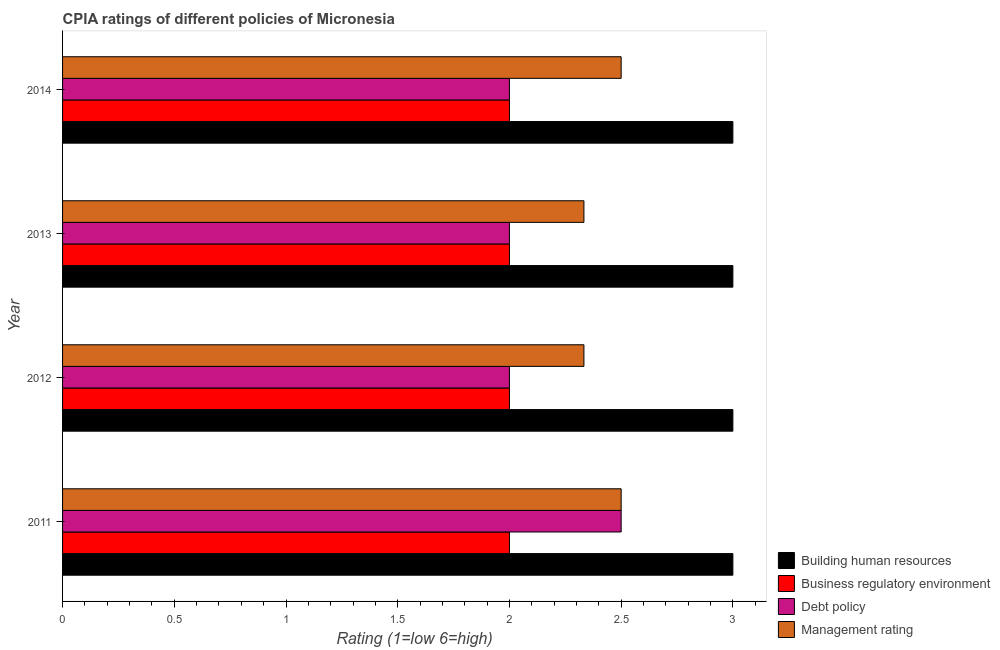How many bars are there on the 4th tick from the top?
Provide a succinct answer. 4. How many bars are there on the 3rd tick from the bottom?
Keep it short and to the point. 4. In how many cases, is the number of bars for a given year not equal to the number of legend labels?
Provide a short and direct response. 0. What is the cpia rating of debt policy in 2014?
Offer a terse response. 2. Across all years, what is the maximum cpia rating of building human resources?
Your answer should be compact. 3. Across all years, what is the minimum cpia rating of building human resources?
Ensure brevity in your answer.  3. In which year was the cpia rating of debt policy maximum?
Your answer should be compact. 2011. What is the total cpia rating of building human resources in the graph?
Provide a short and direct response. 12. What is the difference between the cpia rating of management in 2013 and the cpia rating of debt policy in 2012?
Your answer should be very brief. 0.33. What is the average cpia rating of debt policy per year?
Provide a succinct answer. 2.12. In the year 2013, what is the difference between the cpia rating of business regulatory environment and cpia rating of debt policy?
Ensure brevity in your answer.  0. What is the ratio of the cpia rating of business regulatory environment in 2011 to that in 2013?
Provide a succinct answer. 1. Is the cpia rating of building human resources in 2011 less than that in 2012?
Offer a terse response. No. Is the difference between the cpia rating of management in 2013 and 2014 greater than the difference between the cpia rating of business regulatory environment in 2013 and 2014?
Your response must be concise. No. Is it the case that in every year, the sum of the cpia rating of management and cpia rating of business regulatory environment is greater than the sum of cpia rating of building human resources and cpia rating of debt policy?
Your answer should be compact. Yes. What does the 3rd bar from the top in 2013 represents?
Ensure brevity in your answer.  Business regulatory environment. What does the 4th bar from the bottom in 2012 represents?
Provide a succinct answer. Management rating. Is it the case that in every year, the sum of the cpia rating of building human resources and cpia rating of business regulatory environment is greater than the cpia rating of debt policy?
Ensure brevity in your answer.  Yes. How many bars are there?
Offer a terse response. 16. How many years are there in the graph?
Your response must be concise. 4. Are the values on the major ticks of X-axis written in scientific E-notation?
Provide a succinct answer. No. Does the graph contain any zero values?
Provide a short and direct response. No. How are the legend labels stacked?
Provide a succinct answer. Vertical. What is the title of the graph?
Provide a short and direct response. CPIA ratings of different policies of Micronesia. Does "United Kingdom" appear as one of the legend labels in the graph?
Your answer should be very brief. No. What is the label or title of the X-axis?
Ensure brevity in your answer.  Rating (1=low 6=high). What is the label or title of the Y-axis?
Your answer should be compact. Year. What is the Rating (1=low 6=high) in Debt policy in 2011?
Provide a succinct answer. 2.5. What is the Rating (1=low 6=high) of Management rating in 2011?
Make the answer very short. 2.5. What is the Rating (1=low 6=high) of Building human resources in 2012?
Keep it short and to the point. 3. What is the Rating (1=low 6=high) in Management rating in 2012?
Offer a terse response. 2.33. What is the Rating (1=low 6=high) of Building human resources in 2013?
Your answer should be compact. 3. What is the Rating (1=low 6=high) of Business regulatory environment in 2013?
Provide a succinct answer. 2. What is the Rating (1=low 6=high) of Management rating in 2013?
Offer a very short reply. 2.33. What is the Rating (1=low 6=high) in Business regulatory environment in 2014?
Keep it short and to the point. 2. What is the Rating (1=low 6=high) in Management rating in 2014?
Offer a terse response. 2.5. Across all years, what is the maximum Rating (1=low 6=high) in Building human resources?
Give a very brief answer. 3. Across all years, what is the maximum Rating (1=low 6=high) in Debt policy?
Provide a short and direct response. 2.5. Across all years, what is the minimum Rating (1=low 6=high) of Building human resources?
Make the answer very short. 3. Across all years, what is the minimum Rating (1=low 6=high) in Business regulatory environment?
Give a very brief answer. 2. Across all years, what is the minimum Rating (1=low 6=high) of Debt policy?
Provide a succinct answer. 2. Across all years, what is the minimum Rating (1=low 6=high) in Management rating?
Provide a succinct answer. 2.33. What is the total Rating (1=low 6=high) in Business regulatory environment in the graph?
Give a very brief answer. 8. What is the total Rating (1=low 6=high) of Debt policy in the graph?
Your response must be concise. 8.5. What is the total Rating (1=low 6=high) in Management rating in the graph?
Provide a succinct answer. 9.67. What is the difference between the Rating (1=low 6=high) in Building human resources in 2011 and that in 2012?
Make the answer very short. 0. What is the difference between the Rating (1=low 6=high) in Business regulatory environment in 2011 and that in 2012?
Keep it short and to the point. 0. What is the difference between the Rating (1=low 6=high) of Debt policy in 2011 and that in 2012?
Keep it short and to the point. 0.5. What is the difference between the Rating (1=low 6=high) in Debt policy in 2011 and that in 2013?
Provide a short and direct response. 0.5. What is the difference between the Rating (1=low 6=high) in Building human resources in 2011 and that in 2014?
Provide a short and direct response. 0. What is the difference between the Rating (1=low 6=high) in Business regulatory environment in 2012 and that in 2013?
Your response must be concise. 0. What is the difference between the Rating (1=low 6=high) in Debt policy in 2012 and that in 2013?
Offer a terse response. 0. What is the difference between the Rating (1=low 6=high) of Management rating in 2012 and that in 2013?
Offer a terse response. 0. What is the difference between the Rating (1=low 6=high) in Management rating in 2012 and that in 2014?
Your answer should be very brief. -0.17. What is the difference between the Rating (1=low 6=high) of Building human resources in 2013 and that in 2014?
Your answer should be compact. 0. What is the difference between the Rating (1=low 6=high) of Debt policy in 2013 and that in 2014?
Your answer should be very brief. 0. What is the difference between the Rating (1=low 6=high) in Management rating in 2013 and that in 2014?
Keep it short and to the point. -0.17. What is the difference between the Rating (1=low 6=high) of Building human resources in 2011 and the Rating (1=low 6=high) of Debt policy in 2012?
Make the answer very short. 1. What is the difference between the Rating (1=low 6=high) of Building human resources in 2011 and the Rating (1=low 6=high) of Management rating in 2012?
Your answer should be compact. 0.67. What is the difference between the Rating (1=low 6=high) of Business regulatory environment in 2011 and the Rating (1=low 6=high) of Management rating in 2012?
Give a very brief answer. -0.33. What is the difference between the Rating (1=low 6=high) of Debt policy in 2011 and the Rating (1=low 6=high) of Management rating in 2012?
Provide a short and direct response. 0.17. What is the difference between the Rating (1=low 6=high) in Building human resources in 2011 and the Rating (1=low 6=high) in Business regulatory environment in 2013?
Your response must be concise. 1. What is the difference between the Rating (1=low 6=high) of Business regulatory environment in 2011 and the Rating (1=low 6=high) of Debt policy in 2013?
Provide a short and direct response. 0. What is the difference between the Rating (1=low 6=high) in Debt policy in 2011 and the Rating (1=low 6=high) in Management rating in 2013?
Ensure brevity in your answer.  0.17. What is the difference between the Rating (1=low 6=high) in Building human resources in 2011 and the Rating (1=low 6=high) in Business regulatory environment in 2014?
Keep it short and to the point. 1. What is the difference between the Rating (1=low 6=high) of Business regulatory environment in 2011 and the Rating (1=low 6=high) of Management rating in 2014?
Keep it short and to the point. -0.5. What is the difference between the Rating (1=low 6=high) of Debt policy in 2011 and the Rating (1=low 6=high) of Management rating in 2014?
Keep it short and to the point. 0. What is the difference between the Rating (1=low 6=high) in Building human resources in 2012 and the Rating (1=low 6=high) in Business regulatory environment in 2013?
Make the answer very short. 1. What is the difference between the Rating (1=low 6=high) of Building human resources in 2012 and the Rating (1=low 6=high) of Debt policy in 2013?
Offer a terse response. 1. What is the difference between the Rating (1=low 6=high) in Building human resources in 2012 and the Rating (1=low 6=high) in Management rating in 2013?
Keep it short and to the point. 0.67. What is the difference between the Rating (1=low 6=high) of Business regulatory environment in 2012 and the Rating (1=low 6=high) of Debt policy in 2013?
Offer a terse response. 0. What is the difference between the Rating (1=low 6=high) in Business regulatory environment in 2012 and the Rating (1=low 6=high) in Management rating in 2013?
Ensure brevity in your answer.  -0.33. What is the difference between the Rating (1=low 6=high) in Debt policy in 2012 and the Rating (1=low 6=high) in Management rating in 2013?
Provide a short and direct response. -0.33. What is the difference between the Rating (1=low 6=high) of Building human resources in 2012 and the Rating (1=low 6=high) of Business regulatory environment in 2014?
Offer a terse response. 1. What is the difference between the Rating (1=low 6=high) of Business regulatory environment in 2012 and the Rating (1=low 6=high) of Debt policy in 2014?
Your answer should be compact. 0. What is the difference between the Rating (1=low 6=high) of Business regulatory environment in 2012 and the Rating (1=low 6=high) of Management rating in 2014?
Provide a short and direct response. -0.5. What is the difference between the Rating (1=low 6=high) in Building human resources in 2013 and the Rating (1=low 6=high) in Business regulatory environment in 2014?
Offer a terse response. 1. What is the difference between the Rating (1=low 6=high) of Debt policy in 2013 and the Rating (1=low 6=high) of Management rating in 2014?
Offer a very short reply. -0.5. What is the average Rating (1=low 6=high) of Business regulatory environment per year?
Keep it short and to the point. 2. What is the average Rating (1=low 6=high) of Debt policy per year?
Provide a succinct answer. 2.12. What is the average Rating (1=low 6=high) of Management rating per year?
Give a very brief answer. 2.42. In the year 2011, what is the difference between the Rating (1=low 6=high) of Business regulatory environment and Rating (1=low 6=high) of Management rating?
Your answer should be very brief. -0.5. In the year 2011, what is the difference between the Rating (1=low 6=high) of Debt policy and Rating (1=low 6=high) of Management rating?
Give a very brief answer. 0. In the year 2012, what is the difference between the Rating (1=low 6=high) of Business regulatory environment and Rating (1=low 6=high) of Management rating?
Provide a succinct answer. -0.33. In the year 2012, what is the difference between the Rating (1=low 6=high) in Debt policy and Rating (1=low 6=high) in Management rating?
Ensure brevity in your answer.  -0.33. In the year 2013, what is the difference between the Rating (1=low 6=high) of Building human resources and Rating (1=low 6=high) of Business regulatory environment?
Keep it short and to the point. 1. In the year 2013, what is the difference between the Rating (1=low 6=high) in Building human resources and Rating (1=low 6=high) in Management rating?
Make the answer very short. 0.67. In the year 2013, what is the difference between the Rating (1=low 6=high) of Business regulatory environment and Rating (1=low 6=high) of Debt policy?
Your answer should be very brief. 0. In the year 2013, what is the difference between the Rating (1=low 6=high) in Business regulatory environment and Rating (1=low 6=high) in Management rating?
Give a very brief answer. -0.33. In the year 2014, what is the difference between the Rating (1=low 6=high) in Building human resources and Rating (1=low 6=high) in Debt policy?
Provide a succinct answer. 1. In the year 2014, what is the difference between the Rating (1=low 6=high) in Debt policy and Rating (1=low 6=high) in Management rating?
Offer a terse response. -0.5. What is the ratio of the Rating (1=low 6=high) in Building human resources in 2011 to that in 2012?
Give a very brief answer. 1. What is the ratio of the Rating (1=low 6=high) of Management rating in 2011 to that in 2012?
Offer a very short reply. 1.07. What is the ratio of the Rating (1=low 6=high) of Building human resources in 2011 to that in 2013?
Provide a succinct answer. 1. What is the ratio of the Rating (1=low 6=high) in Business regulatory environment in 2011 to that in 2013?
Keep it short and to the point. 1. What is the ratio of the Rating (1=low 6=high) in Debt policy in 2011 to that in 2013?
Make the answer very short. 1.25. What is the ratio of the Rating (1=low 6=high) in Management rating in 2011 to that in 2013?
Provide a short and direct response. 1.07. What is the ratio of the Rating (1=low 6=high) of Business regulatory environment in 2011 to that in 2014?
Offer a very short reply. 1. What is the ratio of the Rating (1=low 6=high) in Debt policy in 2011 to that in 2014?
Your answer should be very brief. 1.25. What is the ratio of the Rating (1=low 6=high) of Management rating in 2011 to that in 2014?
Provide a short and direct response. 1. What is the ratio of the Rating (1=low 6=high) of Building human resources in 2012 to that in 2013?
Make the answer very short. 1. What is the ratio of the Rating (1=low 6=high) in Debt policy in 2012 to that in 2013?
Offer a very short reply. 1. What is the ratio of the Rating (1=low 6=high) of Management rating in 2012 to that in 2013?
Make the answer very short. 1. What is the ratio of the Rating (1=low 6=high) in Building human resources in 2012 to that in 2014?
Provide a short and direct response. 1. What is the ratio of the Rating (1=low 6=high) in Business regulatory environment in 2012 to that in 2014?
Keep it short and to the point. 1. What is the ratio of the Rating (1=low 6=high) of Building human resources in 2013 to that in 2014?
Your response must be concise. 1. What is the ratio of the Rating (1=low 6=high) in Debt policy in 2013 to that in 2014?
Your response must be concise. 1. What is the difference between the highest and the second highest Rating (1=low 6=high) of Building human resources?
Ensure brevity in your answer.  0. What is the difference between the highest and the lowest Rating (1=low 6=high) in Building human resources?
Offer a very short reply. 0. What is the difference between the highest and the lowest Rating (1=low 6=high) of Management rating?
Make the answer very short. 0.17. 